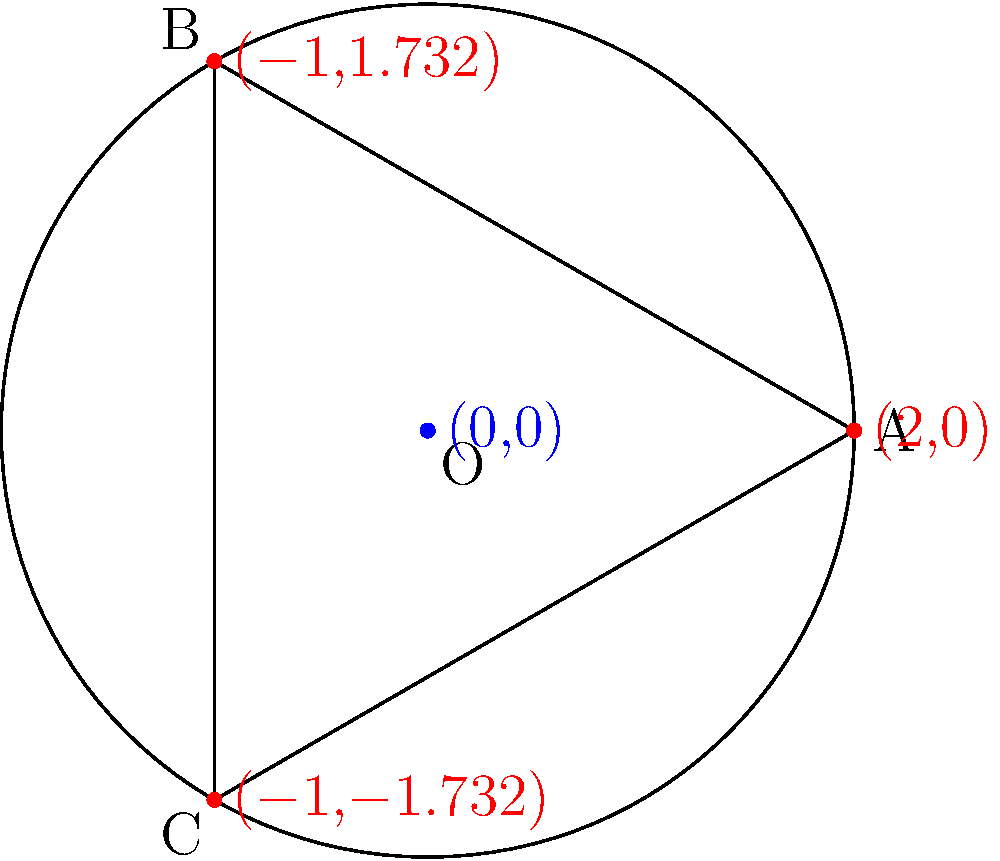In designing a map projection for your fictional planet, you decide to use spherical geometry. If you draw a triangle on the surface of this spherical planet connecting three points A, B, and C, what would be the sum of the interior angles of this triangle compared to a flat Euclidean triangle? To understand this, let's break it down step-by-step:

1. In Euclidean (flat) geometry, the sum of interior angles of a triangle is always 180°.

2. However, on a sphere, triangles behave differently due to the curvature of the surface.

3. On a sphere, the sum of the interior angles of a triangle is always greater than 180°.

4. The excess over 180° is proportional to the area of the triangle on the sphere's surface.

5. This excess is given by the formula: $E = A/R^2$, where E is the excess in radians, A is the area of the triangle on the sphere, and R is the radius of the sphere.

6. The total sum of the angles is thus $180° + E$.

7. This property is known as the Gauss-Bonnet theorem in differential geometry.

8. The larger the triangle on the sphere (i.e., the more surface area it covers), the greater the sum of its angles will be.

9. In the extreme case, if the triangle covers half the sphere, two of its angles will be 90° and the third will approach 180°, for a total approaching 360°.

Therefore, when designing your map projection, you need to account for this angle excess, as it will affect how shapes and distances are represented on your flat map of the spherical planet.
Answer: Greater than 180° 